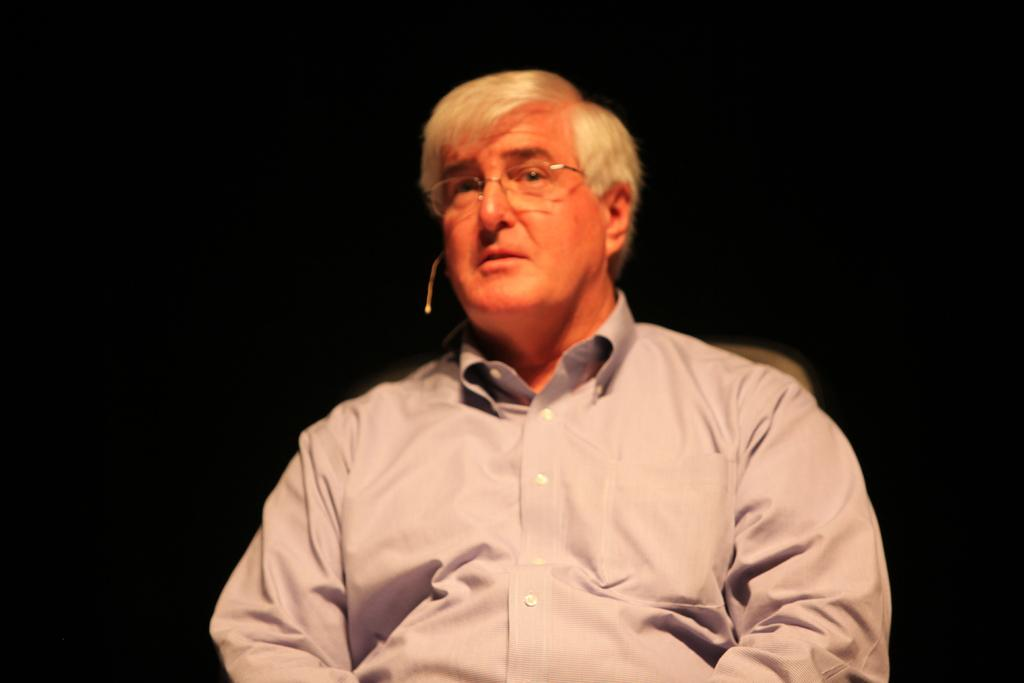Who is the main subject in the image? There is a man in the image. What is the man doing in the image? The man is sitting on a chair. What is the man wearing in the image? The man is wearing a shirt. What can be observed about the man's hair in the image? The man has white hair. How would you describe the background of the image? The background of the image is dark. What type of bun is the man eating in the image? There is no bun present in the image; the man is simply sitting on a chair. How does the man wash his hands in the image? There is no indication of the man washing his hands in the image; he is sitting on a chair with no visible water or soap. 